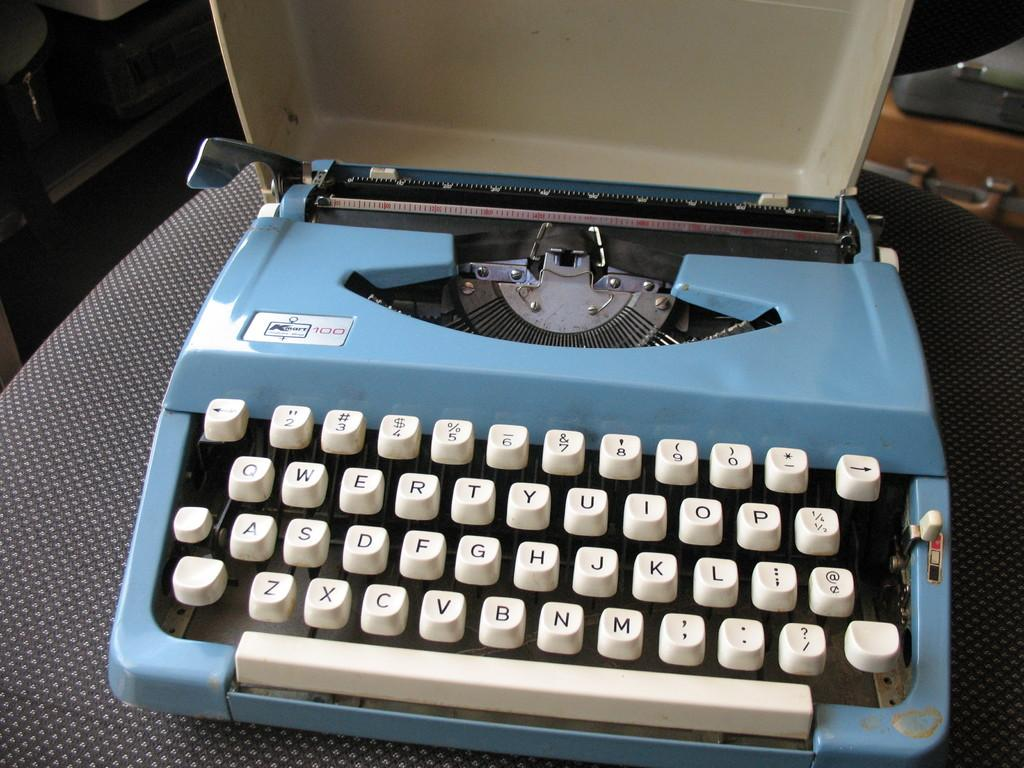<image>
Write a terse but informative summary of the picture. a blue typewriter that has a label that says 100 on it 